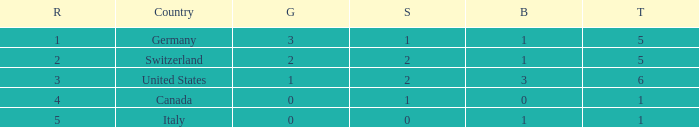How many golds for nations with over 0 silvers, over 1 total, and over 3 bronze? 0.0. 